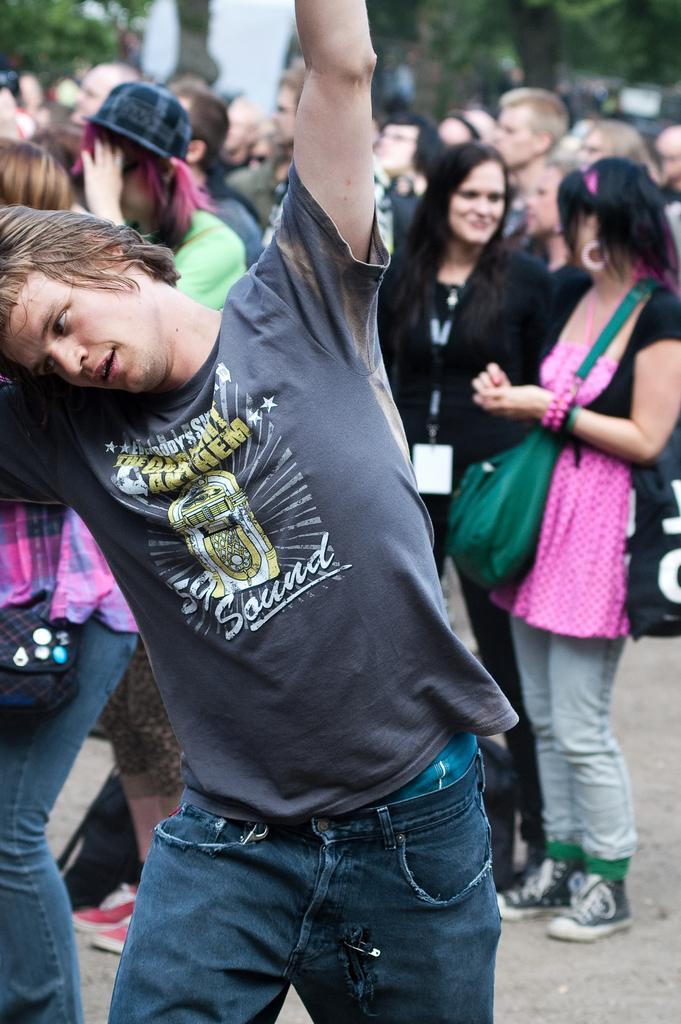Could you give a brief overview of what you see in this image? In this image I can see a person standing in the front, wearing a t shirt and jeans. There are other people at the back. There are trees. 